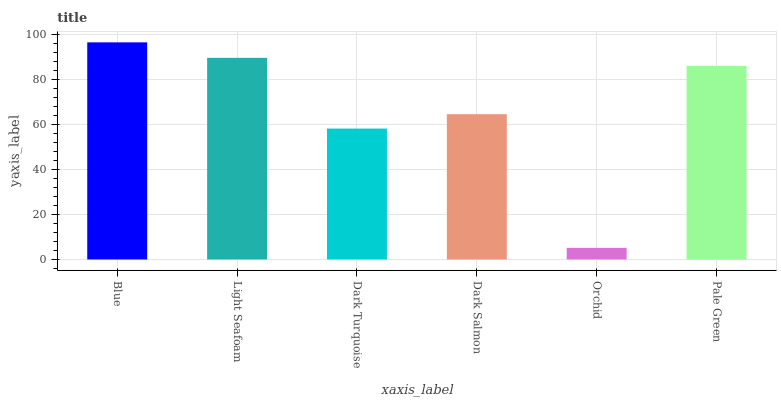Is Orchid the minimum?
Answer yes or no. Yes. Is Blue the maximum?
Answer yes or no. Yes. Is Light Seafoam the minimum?
Answer yes or no. No. Is Light Seafoam the maximum?
Answer yes or no. No. Is Blue greater than Light Seafoam?
Answer yes or no. Yes. Is Light Seafoam less than Blue?
Answer yes or no. Yes. Is Light Seafoam greater than Blue?
Answer yes or no. No. Is Blue less than Light Seafoam?
Answer yes or no. No. Is Pale Green the high median?
Answer yes or no. Yes. Is Dark Salmon the low median?
Answer yes or no. Yes. Is Dark Turquoise the high median?
Answer yes or no. No. Is Dark Turquoise the low median?
Answer yes or no. No. 